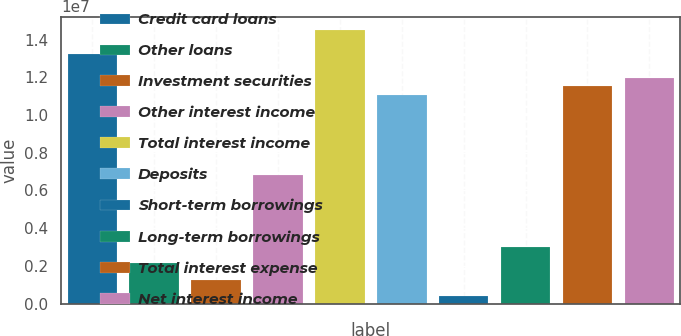<chart> <loc_0><loc_0><loc_500><loc_500><bar_chart><fcel>Credit card loans<fcel>Other loans<fcel>Investment securities<fcel>Other interest income<fcel>Total interest income<fcel>Deposits<fcel>Short-term borrowings<fcel>Long-term borrowings<fcel>Total interest expense<fcel>Net interest income<nl><fcel>1.32198e+07<fcel>2.13223e+06<fcel>1.27934e+06<fcel>6.82313e+06<fcel>1.44992e+07<fcel>1.10876e+07<fcel>426446<fcel>2.98512e+06<fcel>1.1514e+07<fcel>1.19405e+07<nl></chart> 